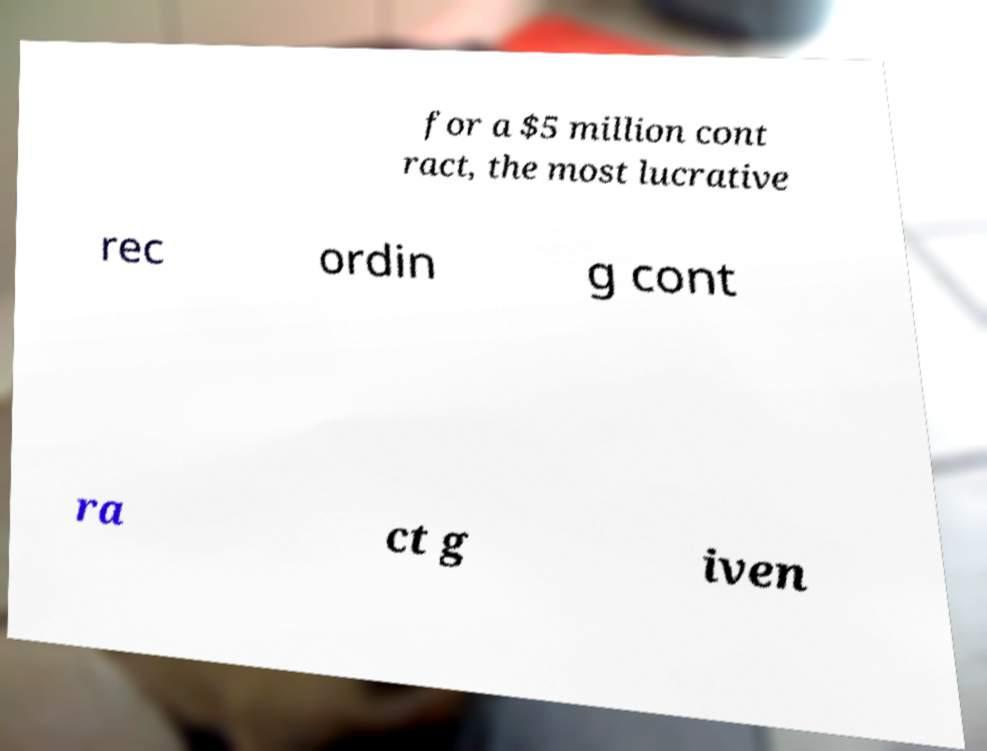There's text embedded in this image that I need extracted. Can you transcribe it verbatim? for a $5 million cont ract, the most lucrative rec ordin g cont ra ct g iven 